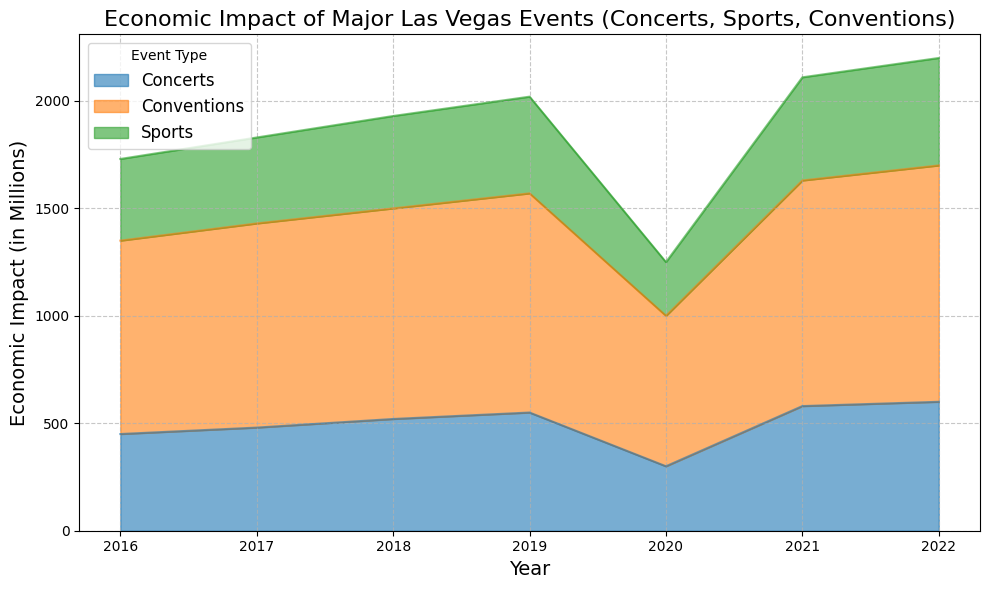What event had the highest economic impact in 2022? To find this, look at the heights of the stacked areas in the plot for 2022. The highest single segment corresponds to Conventions, which is 1100 million.
Answer: Conventions How did the economic impact of Concerts change from 2019 to 2020? Compare the height of the Concerts area segment between 2019 and 2020. In 2019, the value is 550 million, and in 2020, it dropped to 300 million. The difference is a decrease of 250 million.
Answer: Decreased by 250 million Which year experienced the lowest overall economic impact for all events combined? Observe the overall height of the stacked areas for each year. The smallest total height is observed in 2020.
Answer: 2020 By how much did the economic impact of Conventions increase from 2016 to 2022? Compare the height of the Conventions area segment between 2016 and 2022. In 2016 it was 900 million, and in 2022 it rose to 1100 million. The difference is an increase of 200 million.
Answer: Increased by 200 million In what year did Sports have an economic impact greater than 400 million for the first time? Look at the heights of the Sports area segment each year to see when it first surpasses 400 million. This first occurs in 2017, with an economic impact of 400 million.
Answer: 2017 Which type of event showed the most consistent growth in economic impact over the years? Examine the trends of each event type’s area segment over the years. Conventions show the most consistent increase every year, apart from a drop in 2020.
Answer: Conventions What was the total economic impact of all events in 2018? Add the heights of all area segments for 2018. Concerts (520) + Sports (430) + Conventions (980) = 1930 million.
Answer: 1930 million By how much did the economic impact of Sports change from 2016 to 2021? Compare the height of the Sports area segment between 2016 and 2021. In 2016, it was 380 million, and in 2021, it rose to 480 million. The difference is an increase of 100 million.
Answer: Increased by 100 million What is the average economic impact of Concerts from 2016 to 2022? Sum the economic impact values of Concerts from 2016 to 2022, then divide by the number of years (7). (450 + 480 + 520 + 550 + 300 + 580 + 600) / 7 = 495.7 million.
Answer: 495.7 million Which event had the least economic impact in 2020? Find the smallest area segment in 2020. Sports had the least economic impact at 250 million.
Answer: Sports 